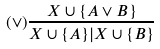<formula> <loc_0><loc_0><loc_500><loc_500>( \vee ) \frac { X \cup \{ A \vee B \} } { X \cup \{ A \} | X \cup \{ B \} }</formula> 